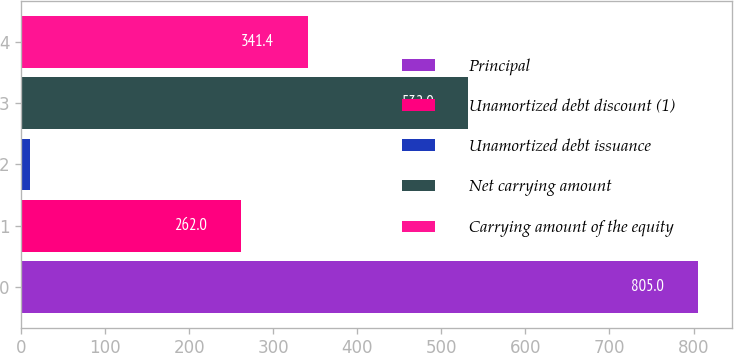Convert chart to OTSL. <chart><loc_0><loc_0><loc_500><loc_500><bar_chart><fcel>Principal<fcel>Unamortized debt discount (1)<fcel>Unamortized debt issuance<fcel>Net carrying amount<fcel>Carrying amount of the equity<nl><fcel>805<fcel>262<fcel>11<fcel>532<fcel>341.4<nl></chart> 